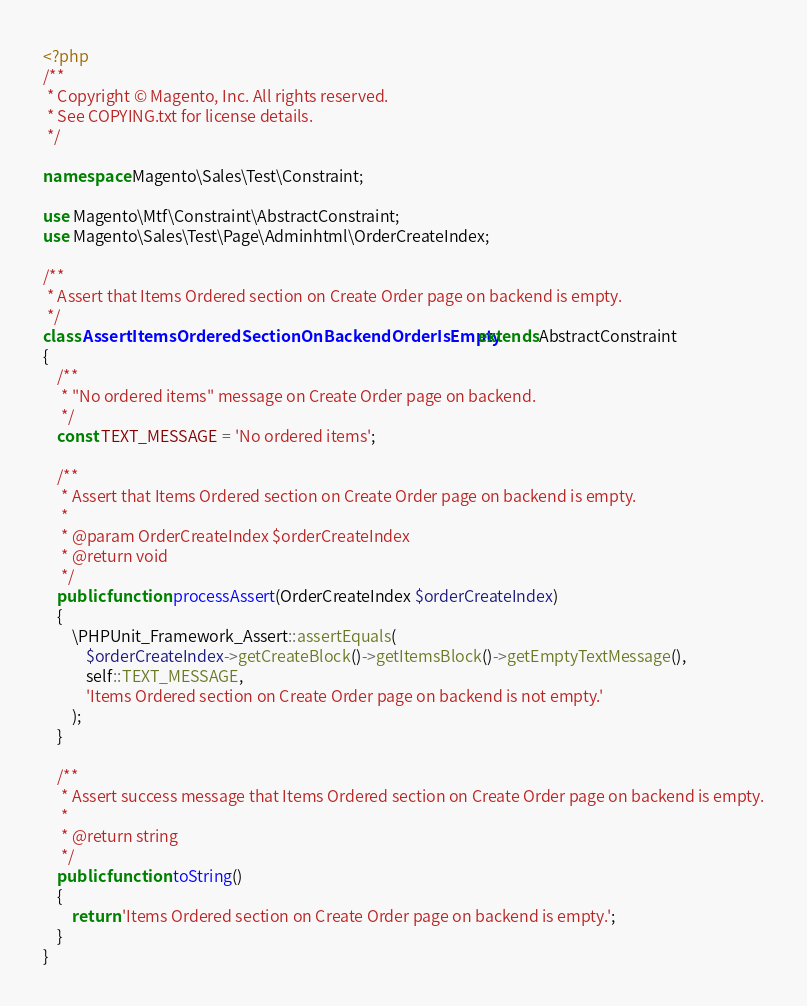Convert code to text. <code><loc_0><loc_0><loc_500><loc_500><_PHP_><?php
/**
 * Copyright © Magento, Inc. All rights reserved.
 * See COPYING.txt for license details.
 */

namespace Magento\Sales\Test\Constraint;

use Magento\Mtf\Constraint\AbstractConstraint;
use Magento\Sales\Test\Page\Adminhtml\OrderCreateIndex;

/**
 * Assert that Items Ordered section on Create Order page on backend is empty.
 */
class AssertItemsOrderedSectionOnBackendOrderIsEmpty extends AbstractConstraint
{
    /**
     * "No ordered items" message on Create Order page on backend.
     */
    const TEXT_MESSAGE = 'No ordered items';

    /**
     * Assert that Items Ordered section on Create Order page on backend is empty.
     *
     * @param OrderCreateIndex $orderCreateIndex
     * @return void
     */
    public function processAssert(OrderCreateIndex $orderCreateIndex)
    {
        \PHPUnit_Framework_Assert::assertEquals(
            $orderCreateIndex->getCreateBlock()->getItemsBlock()->getEmptyTextMessage(),
            self::TEXT_MESSAGE,
            'Items Ordered section on Create Order page on backend is not empty.'
        );
    }

    /**
     * Assert success message that Items Ordered section on Create Order page on backend is empty.
     *
     * @return string
     */
    public function toString()
    {
        return 'Items Ordered section on Create Order page on backend is empty.';
    }
}
</code> 